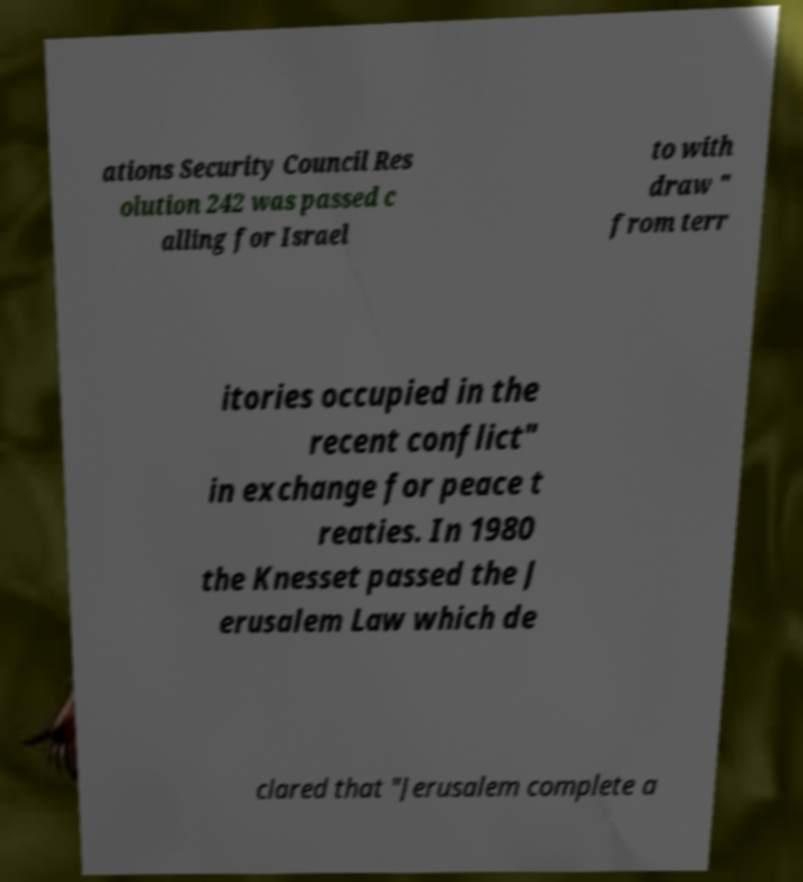For documentation purposes, I need the text within this image transcribed. Could you provide that? ations Security Council Res olution 242 was passed c alling for Israel to with draw " from terr itories occupied in the recent conflict" in exchange for peace t reaties. In 1980 the Knesset passed the J erusalem Law which de clared that "Jerusalem complete a 